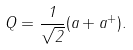<formula> <loc_0><loc_0><loc_500><loc_500>Q = \frac { 1 } { \sqrt { 2 } } ( a + a ^ { + } ) .</formula> 